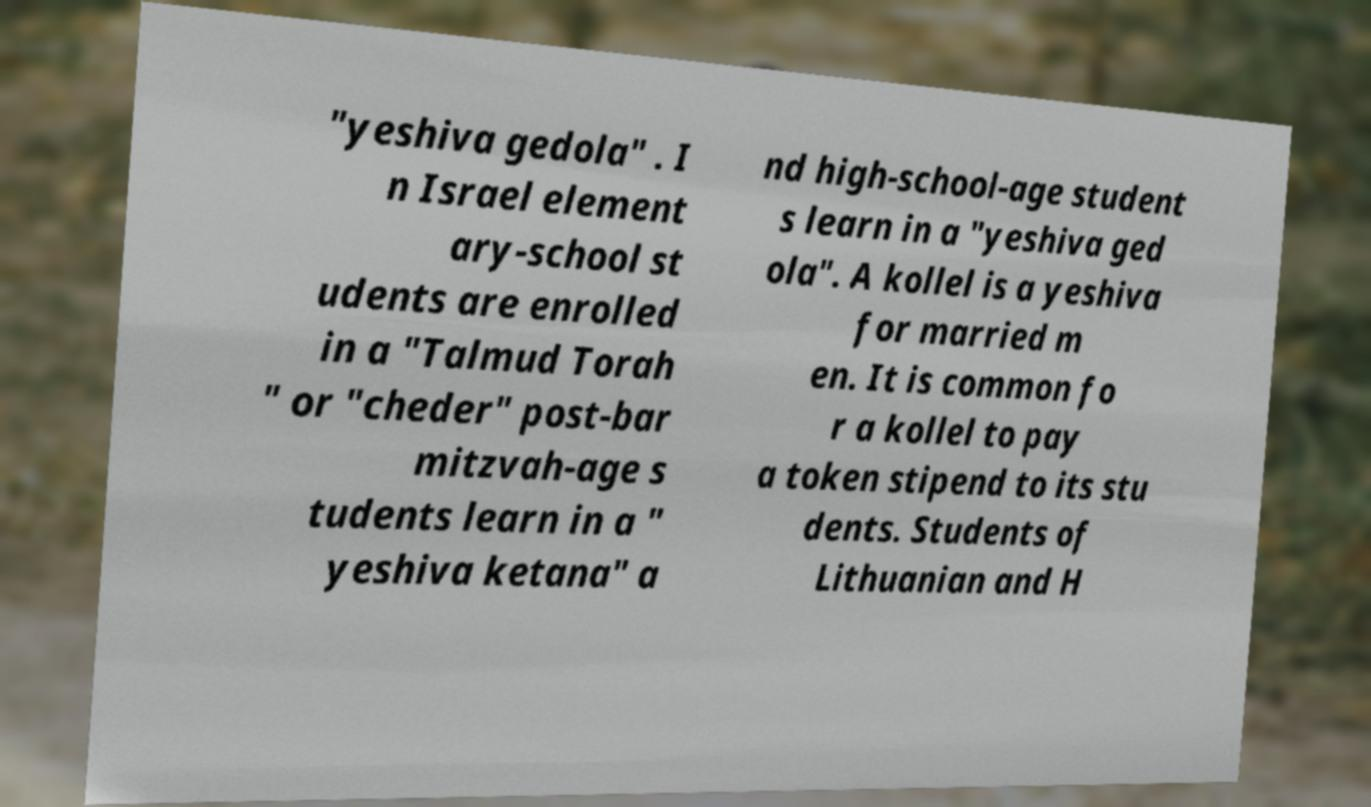What messages or text are displayed in this image? I need them in a readable, typed format. "yeshiva gedola" . I n Israel element ary-school st udents are enrolled in a "Talmud Torah " or "cheder" post-bar mitzvah-age s tudents learn in a " yeshiva ketana" a nd high-school-age student s learn in a "yeshiva ged ola". A kollel is a yeshiva for married m en. It is common fo r a kollel to pay a token stipend to its stu dents. Students of Lithuanian and H 